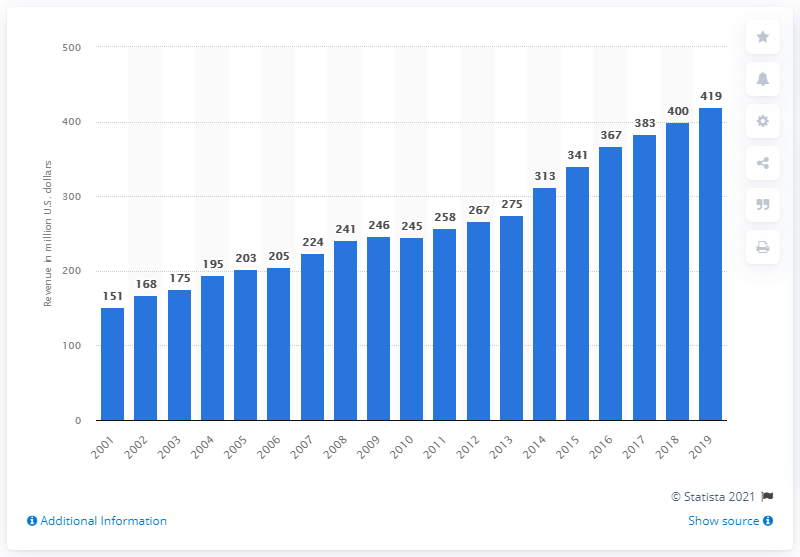What was the revenue of the Tampa Bay Buccaneers in 2019?
 419 